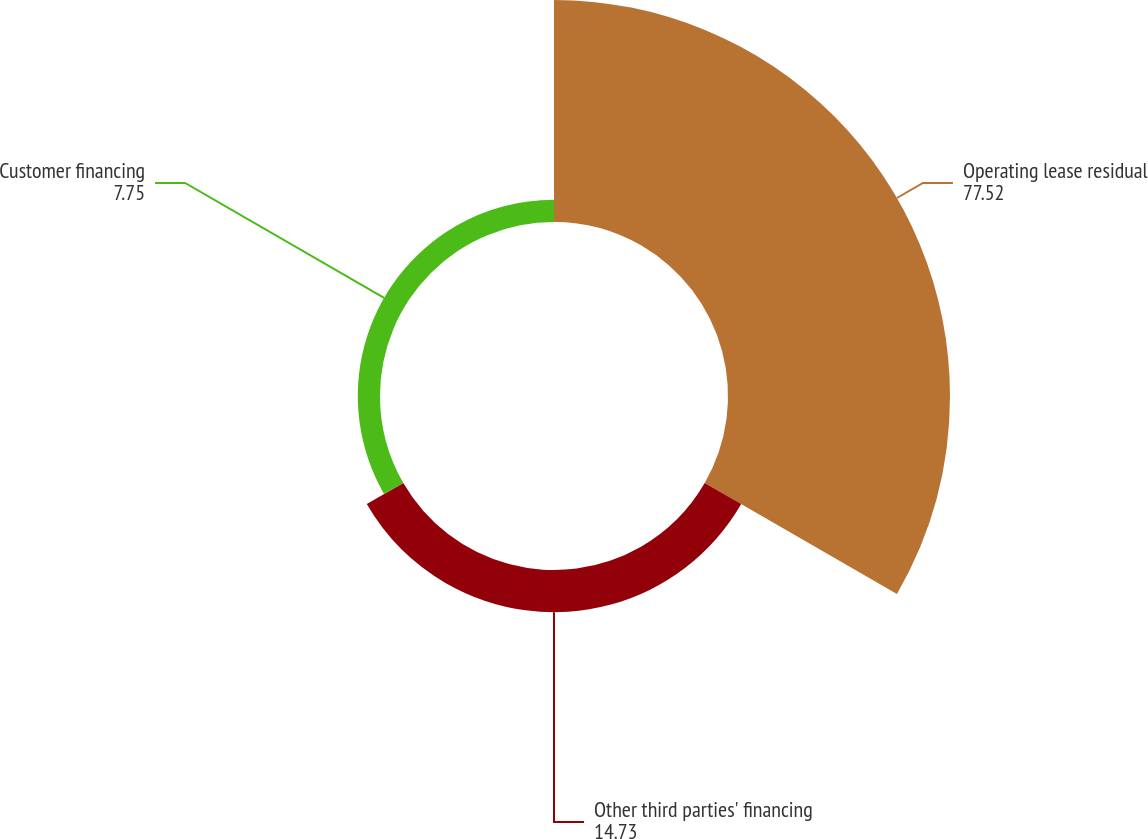<chart> <loc_0><loc_0><loc_500><loc_500><pie_chart><fcel>Operating lease residual<fcel>Other third parties' financing<fcel>Customer financing<nl><fcel>77.52%<fcel>14.73%<fcel>7.75%<nl></chart> 